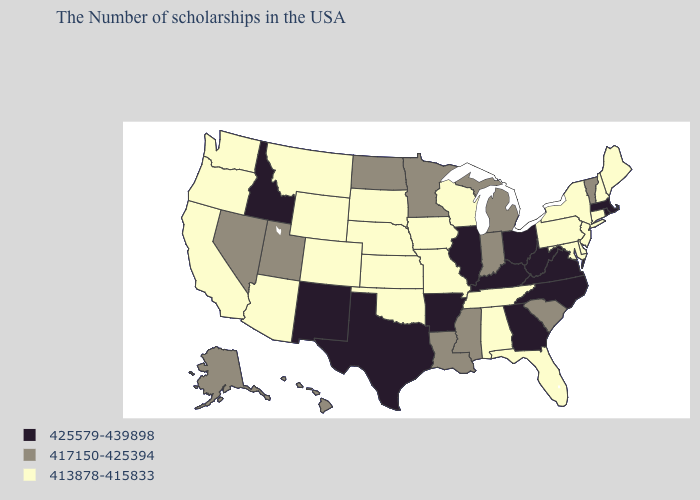Does Vermont have the lowest value in the Northeast?
Concise answer only. No. Among the states that border Texas , which have the highest value?
Short answer required. Arkansas, New Mexico. Among the states that border Wyoming , which have the highest value?
Give a very brief answer. Idaho. What is the value of Colorado?
Concise answer only. 413878-415833. What is the value of Vermont?
Keep it brief. 417150-425394. Does Mississippi have a higher value than Kentucky?
Answer briefly. No. Is the legend a continuous bar?
Short answer required. No. What is the lowest value in the West?
Be succinct. 413878-415833. What is the value of Arizona?
Short answer required. 413878-415833. Name the states that have a value in the range 417150-425394?
Keep it brief. Vermont, South Carolina, Michigan, Indiana, Mississippi, Louisiana, Minnesota, North Dakota, Utah, Nevada, Alaska, Hawaii. Which states have the lowest value in the USA?
Answer briefly. Maine, New Hampshire, Connecticut, New York, New Jersey, Delaware, Maryland, Pennsylvania, Florida, Alabama, Tennessee, Wisconsin, Missouri, Iowa, Kansas, Nebraska, Oklahoma, South Dakota, Wyoming, Colorado, Montana, Arizona, California, Washington, Oregon. Does Nevada have the same value as Pennsylvania?
Quick response, please. No. Which states have the lowest value in the USA?
Write a very short answer. Maine, New Hampshire, Connecticut, New York, New Jersey, Delaware, Maryland, Pennsylvania, Florida, Alabama, Tennessee, Wisconsin, Missouri, Iowa, Kansas, Nebraska, Oklahoma, South Dakota, Wyoming, Colorado, Montana, Arizona, California, Washington, Oregon. What is the highest value in the MidWest ?
Give a very brief answer. 425579-439898. How many symbols are there in the legend?
Write a very short answer. 3. 